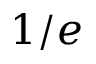Convert formula to latex. <formula><loc_0><loc_0><loc_500><loc_500>1 / e</formula> 